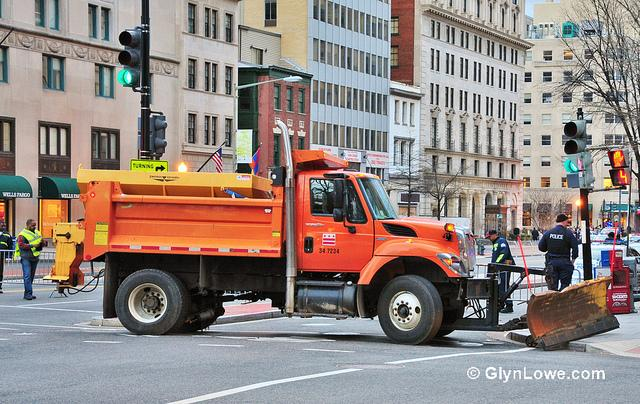Why is the man wearing a yellow vest?

Choices:
A) fashion
B) visibility
C) camouflage
D) costume visibility 